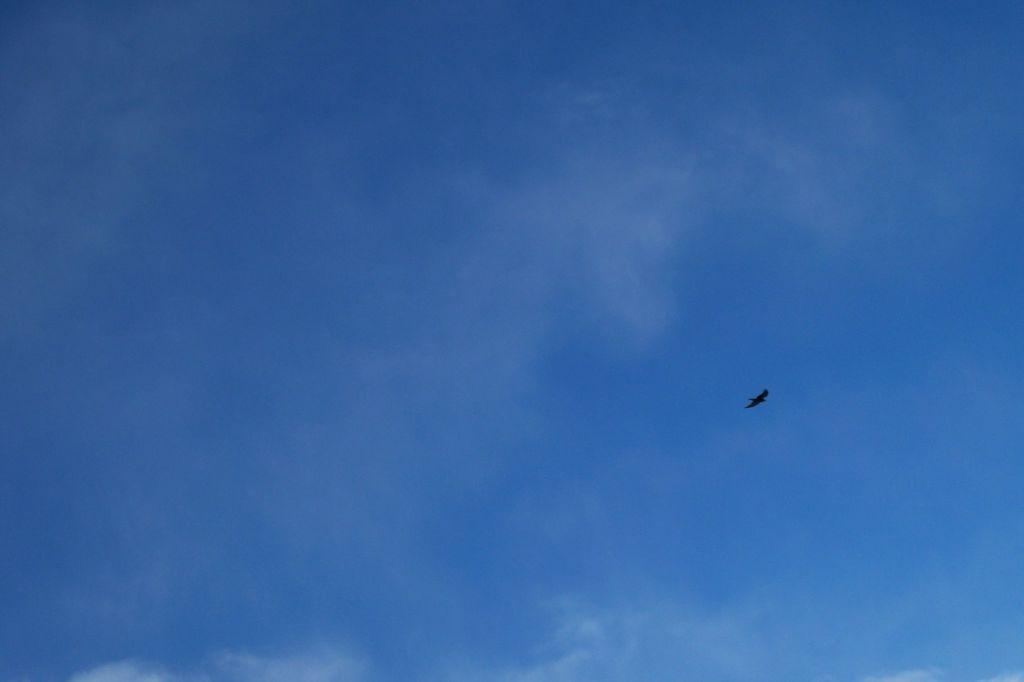What is the main subject of the image? There is a bird flying in the image. On which side of the image is the bird located? The bird is on the right side of the image. What can be seen in the background of the image? There is sky visible in the background of the image. What does the kitten desire from the bird in the image? There is no kitten present in the image, so it is not possible to determine any desires it might have. 